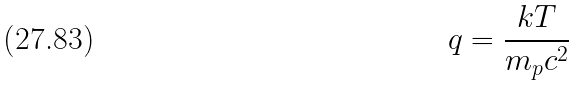Convert formula to latex. <formula><loc_0><loc_0><loc_500><loc_500>q = \frac { k T } { m _ { p } c ^ { 2 } }</formula> 